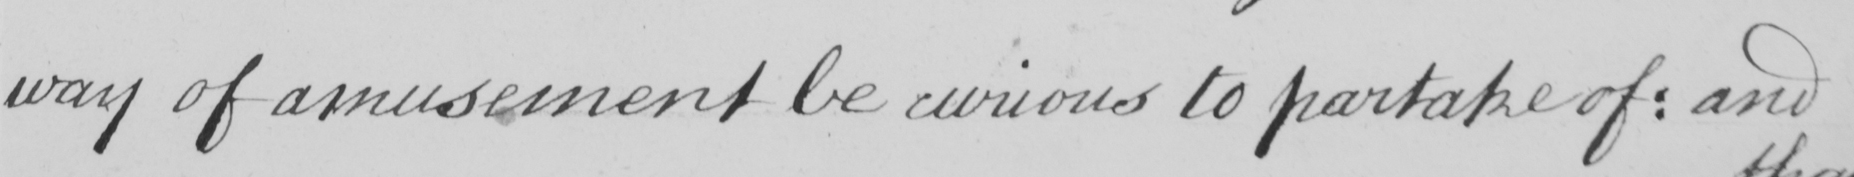Please provide the text content of this handwritten line. way of amusement be curious to partake of :  and 